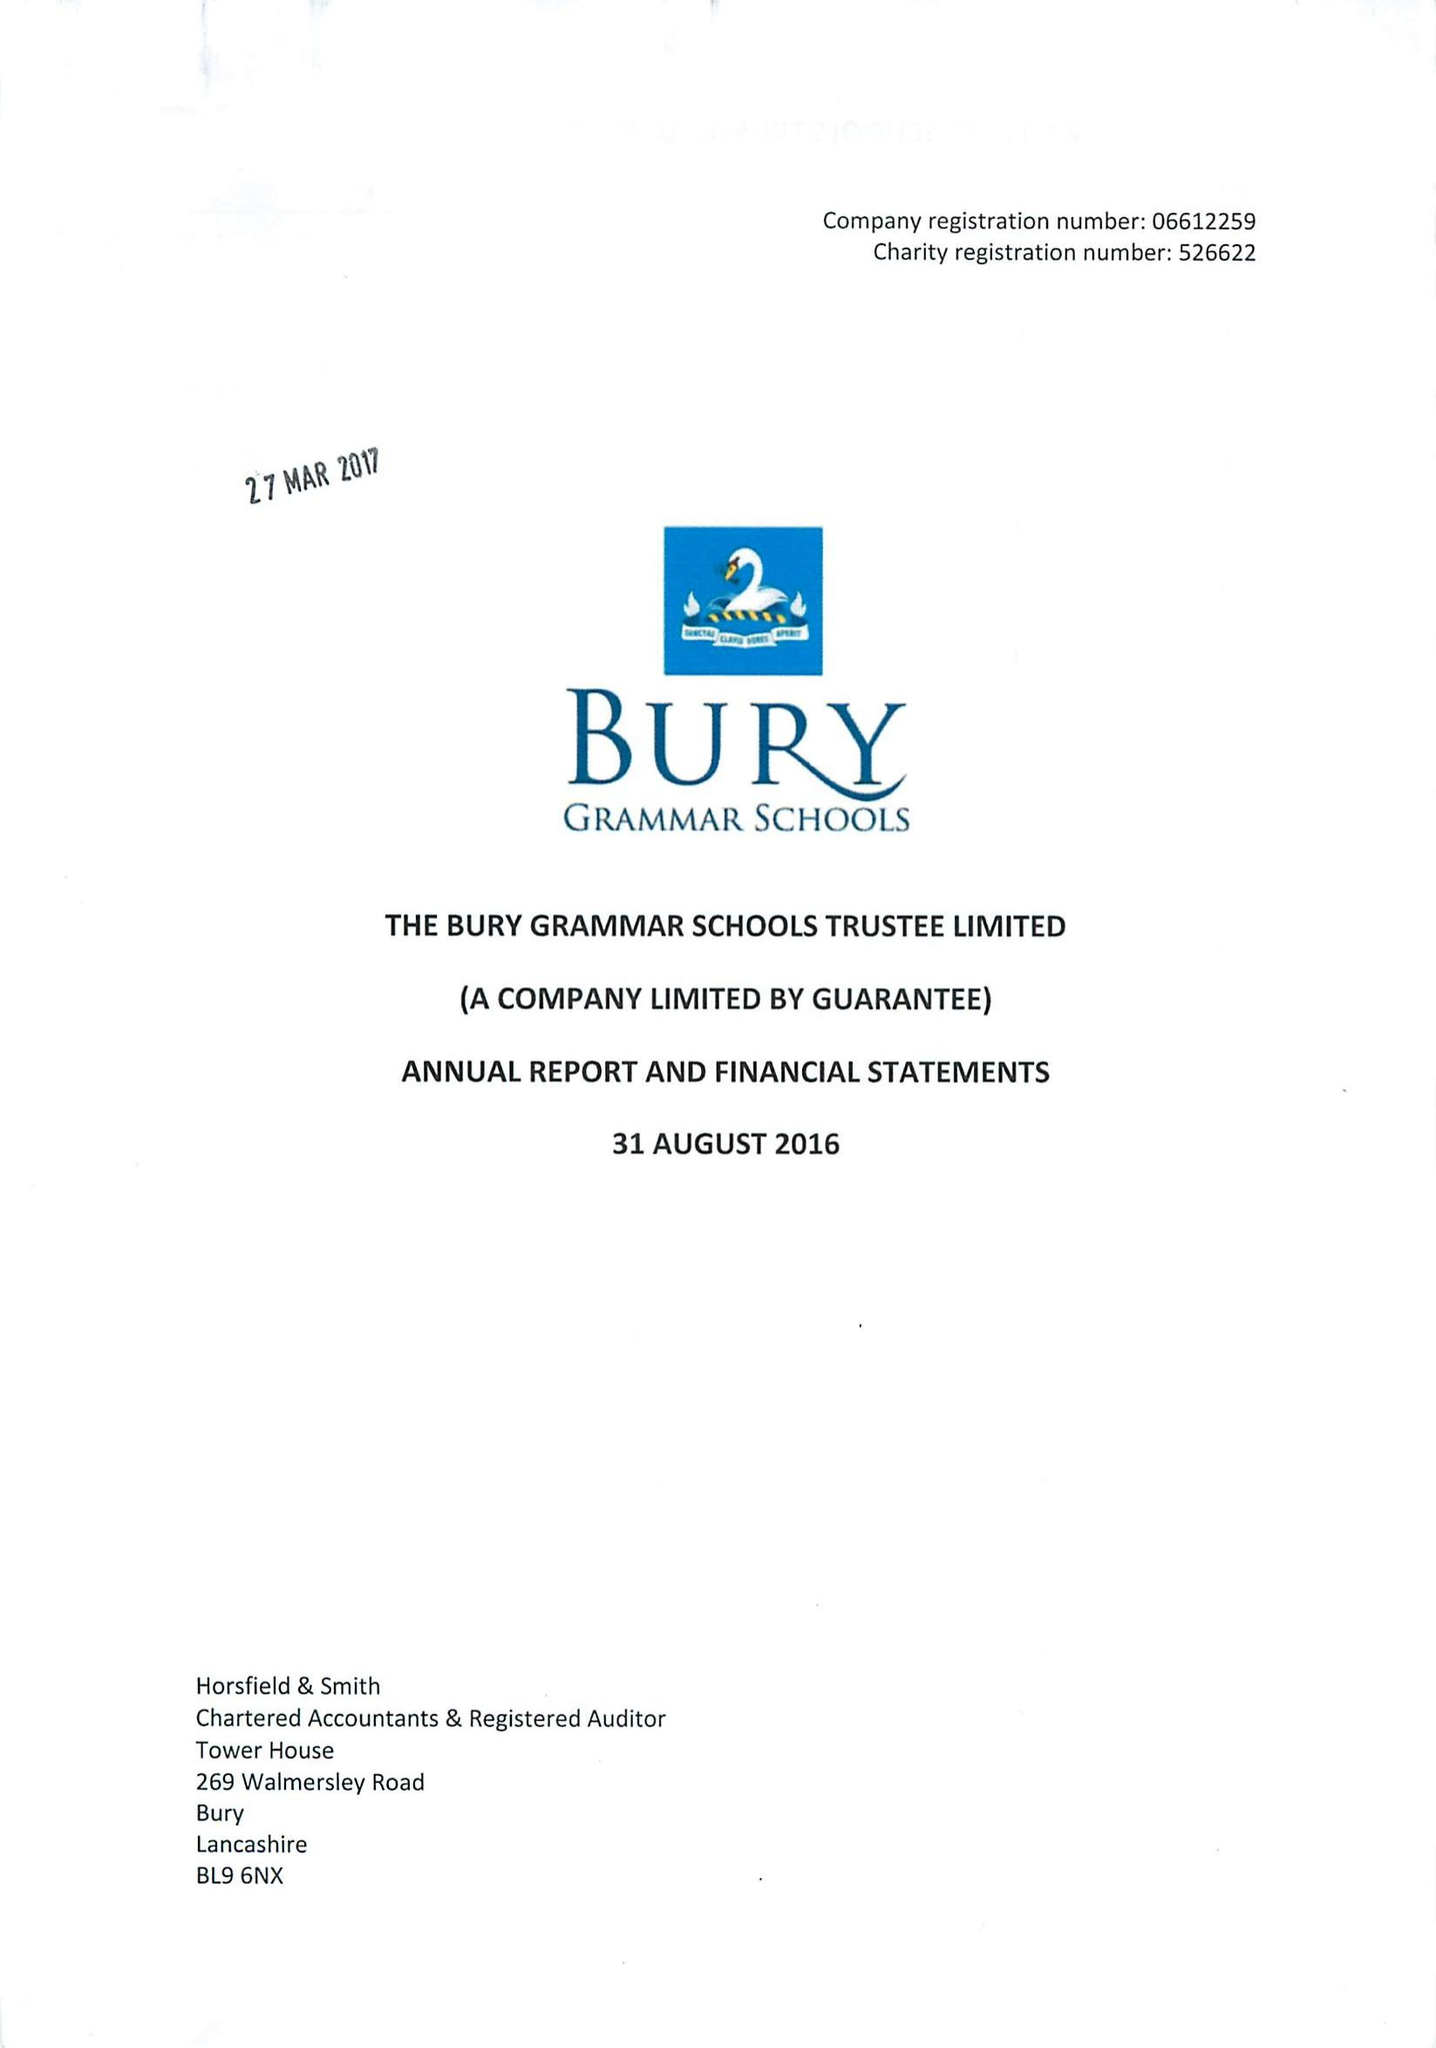What is the value for the charity_number?
Answer the question using a single word or phrase. 526622 